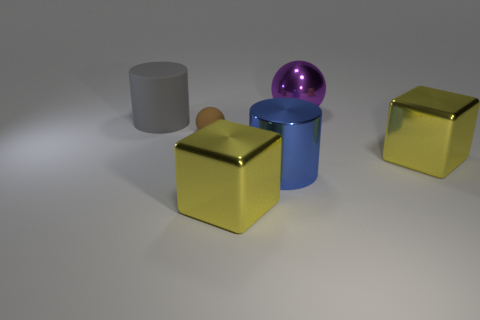What color is the metal cylinder that is the same size as the gray thing?
Ensure brevity in your answer.  Blue. What number of things are either cylinders behind the brown rubber thing or objects behind the big blue cylinder?
Ensure brevity in your answer.  4. How many things are either large blue cylinders or brown shiny cylinders?
Provide a short and direct response. 1. There is a metallic thing that is right of the large blue shiny cylinder and in front of the gray thing; how big is it?
Your answer should be compact. Large. How many big cylinders are the same material as the gray object?
Your answer should be very brief. 0. What is the color of the cylinder that is the same material as the brown thing?
Provide a short and direct response. Gray. There is a large cylinder that is in front of the big matte cylinder; does it have the same color as the large rubber thing?
Make the answer very short. No. There is a cylinder that is in front of the brown thing; what is its material?
Ensure brevity in your answer.  Metal. Are there an equal number of things that are behind the big blue cylinder and big purple metallic spheres?
Give a very brief answer. No. What number of other tiny spheres have the same color as the small rubber sphere?
Your response must be concise. 0. 